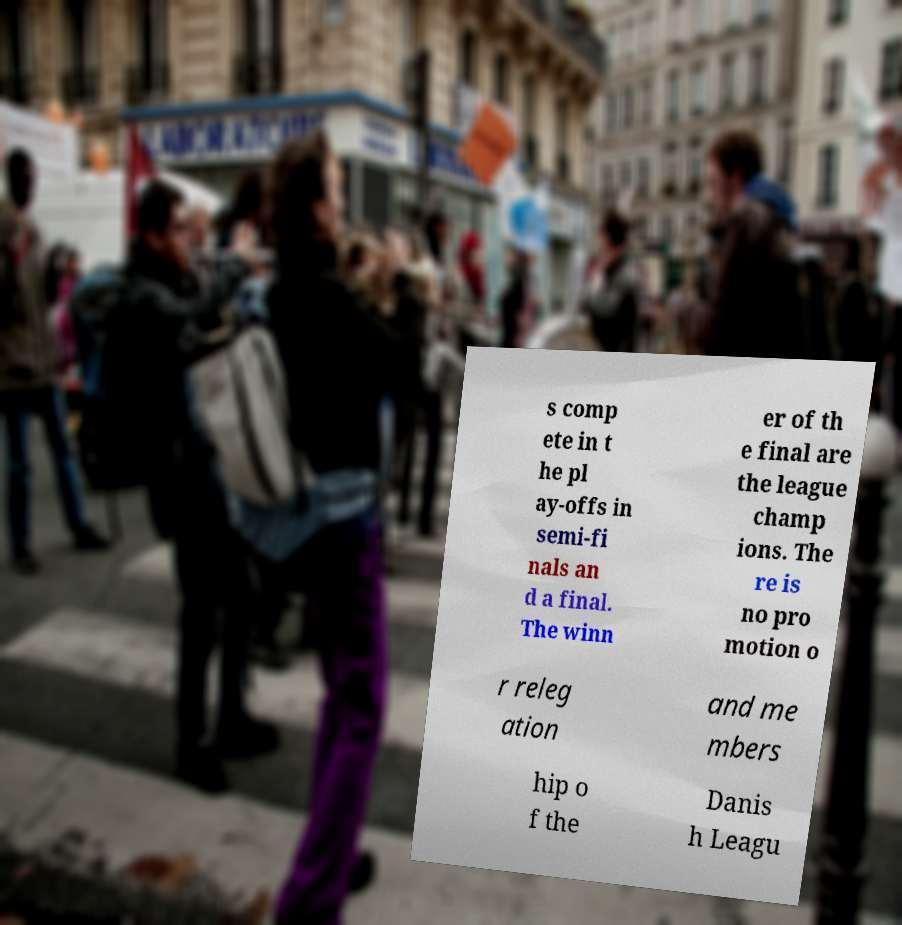Can you accurately transcribe the text from the provided image for me? s comp ete in t he pl ay-offs in semi-fi nals an d a final. The winn er of th e final are the league champ ions. The re is no pro motion o r releg ation and me mbers hip o f the Danis h Leagu 